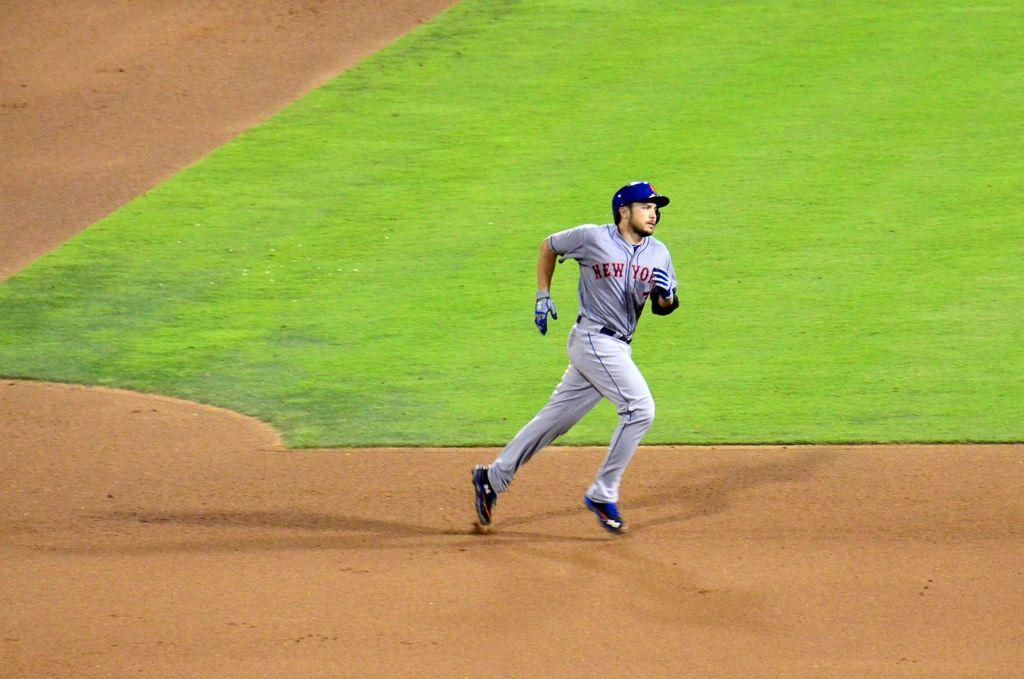<image>
Summarize the visual content of the image. The person running is on the team from New York 